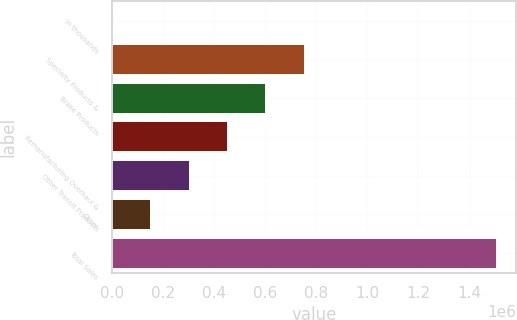Convert chart. <chart><loc_0><loc_0><loc_500><loc_500><bar_chart><fcel>In thousands<fcel>Specialty Products &<fcel>Brake Products<fcel>Remanufacturing Overhaul &<fcel>Other Transit Products<fcel>Other<fcel>Total Sales<nl><fcel>2010<fcel>754511<fcel>604011<fcel>453511<fcel>303010<fcel>152510<fcel>1.50701e+06<nl></chart> 